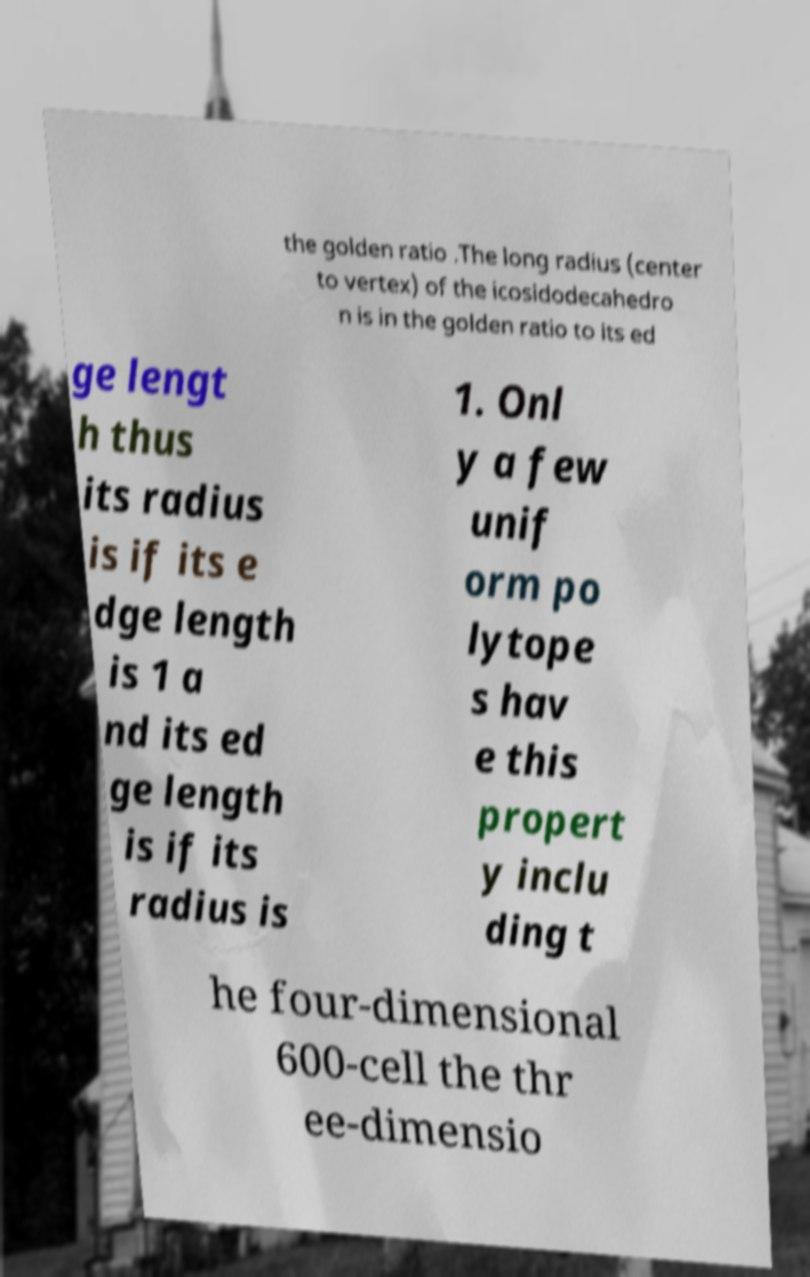Could you extract and type out the text from this image? the golden ratio .The long radius (center to vertex) of the icosidodecahedro n is in the golden ratio to its ed ge lengt h thus its radius is if its e dge length is 1 a nd its ed ge length is if its radius is 1. Onl y a few unif orm po lytope s hav e this propert y inclu ding t he four-dimensional 600-cell the thr ee-dimensio 